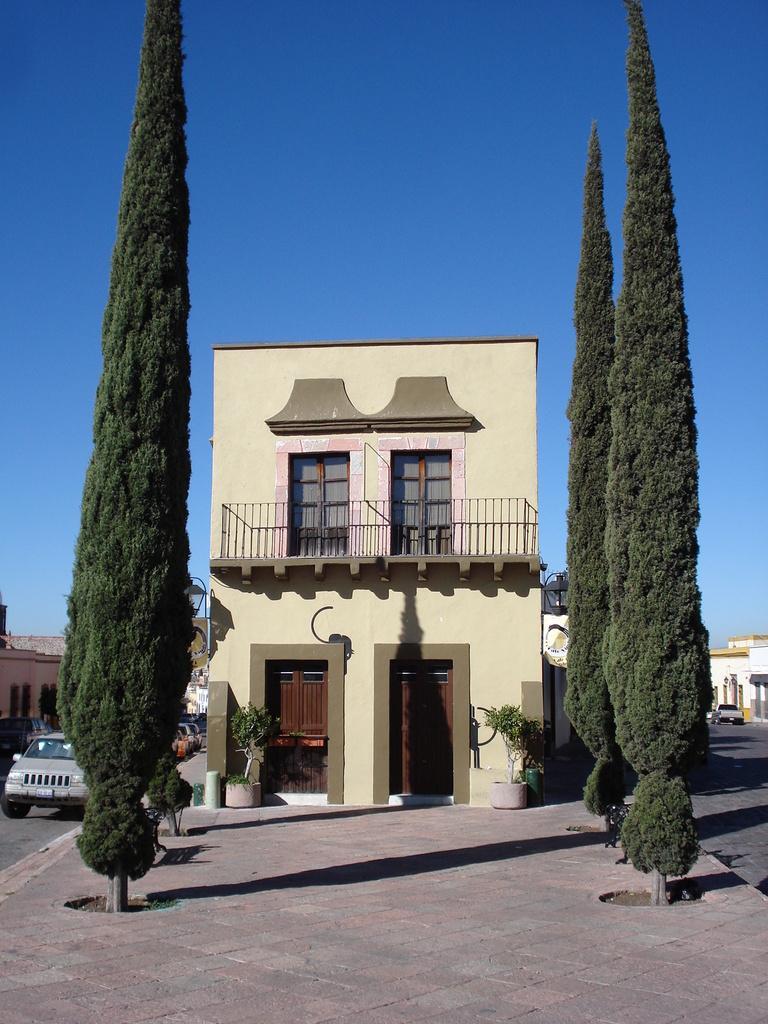Could you give a brief overview of what you see in this image? At the bottom of the picture, we see the pavement. On either side of the pavement, we see the trees. In the middle, we see a building. It has windows, railing and doors. On either side of the building, we see the plant pots. On the right side, we see the buildings in white color and we see the car is moving on the road. On the left side, we see the buildings and cars. At the top, we see the sky, which is blue in color. 